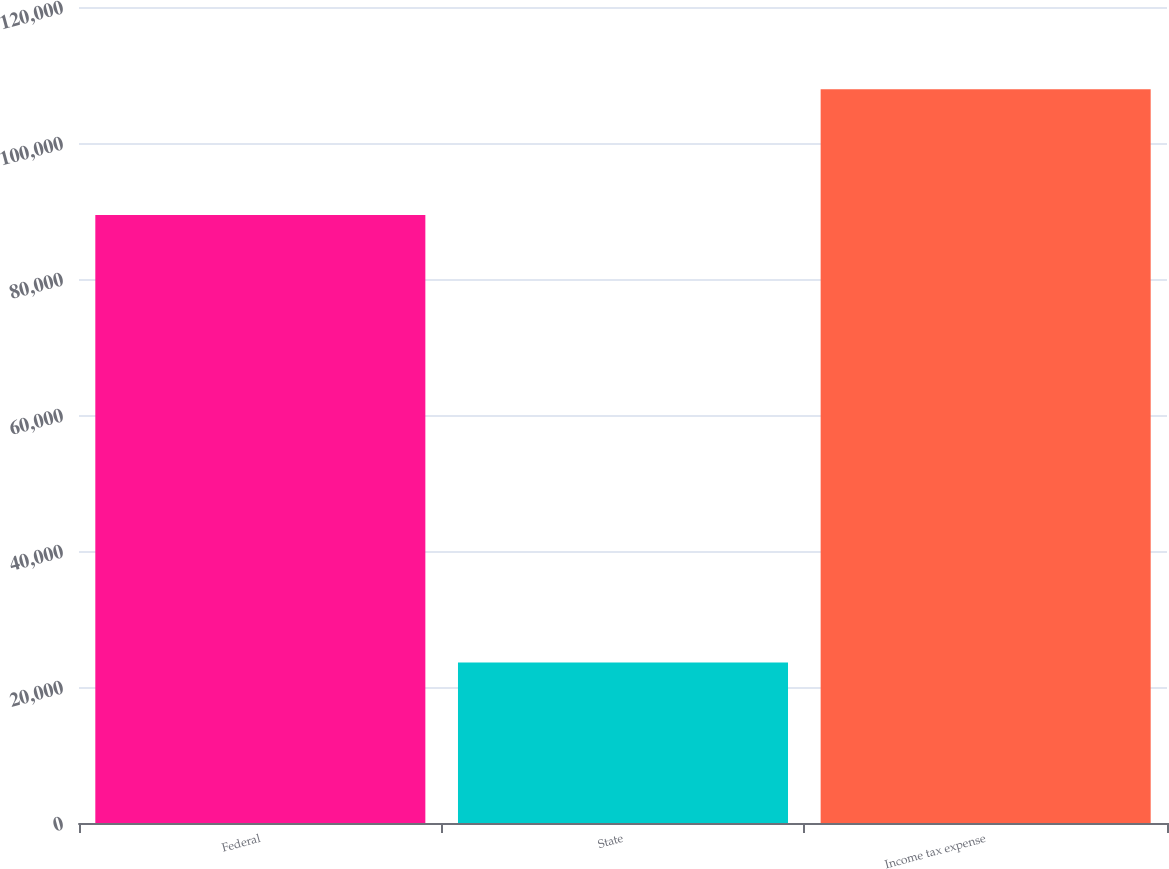Convert chart to OTSL. <chart><loc_0><loc_0><loc_500><loc_500><bar_chart><fcel>Federal<fcel>State<fcel>Income tax expense<nl><fcel>89415<fcel>23619<fcel>107907<nl></chart> 